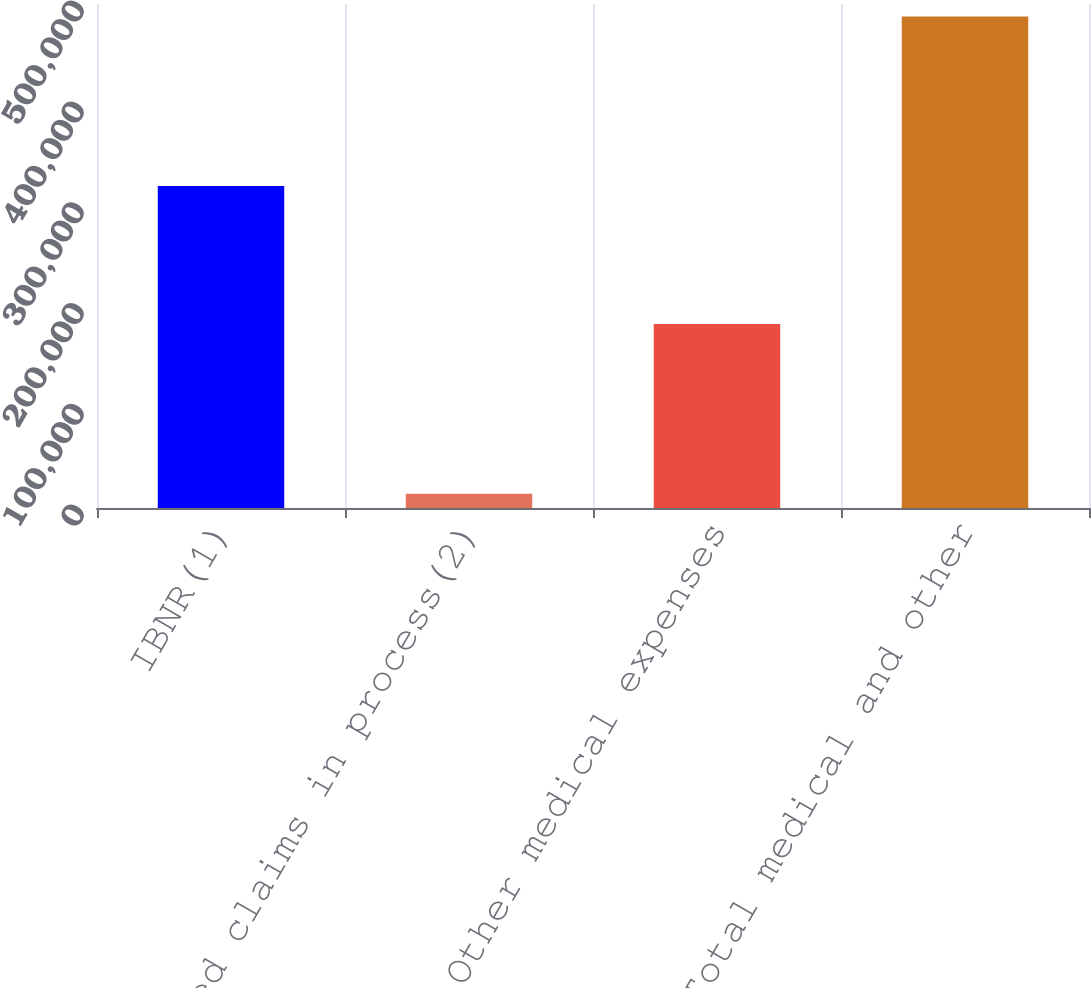<chart> <loc_0><loc_0><loc_500><loc_500><bar_chart><fcel>IBNR(1)<fcel>Reported claims in process(2)<fcel>Other medical expenses<fcel>Total medical and other<nl><fcel>319384<fcel>14166<fcel>182454<fcel>487672<nl></chart> 